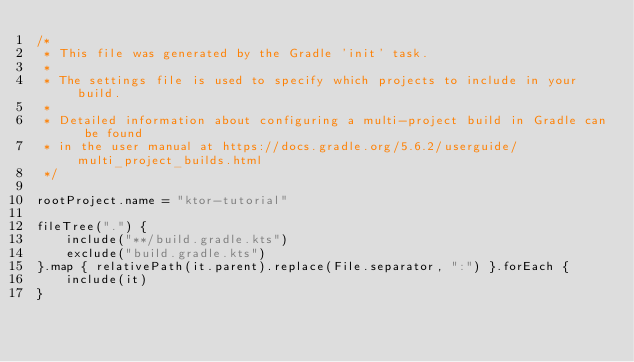Convert code to text. <code><loc_0><loc_0><loc_500><loc_500><_Kotlin_>/*
 * This file was generated by the Gradle 'init' task.
 *
 * The settings file is used to specify which projects to include in your build.
 *
 * Detailed information about configuring a multi-project build in Gradle can be found
 * in the user manual at https://docs.gradle.org/5.6.2/userguide/multi_project_builds.html
 */

rootProject.name = "ktor-tutorial"

fileTree(".") {
    include("**/build.gradle.kts")
    exclude("build.gradle.kts")
}.map { relativePath(it.parent).replace(File.separator, ":") }.forEach {
    include(it)
}
</code> 